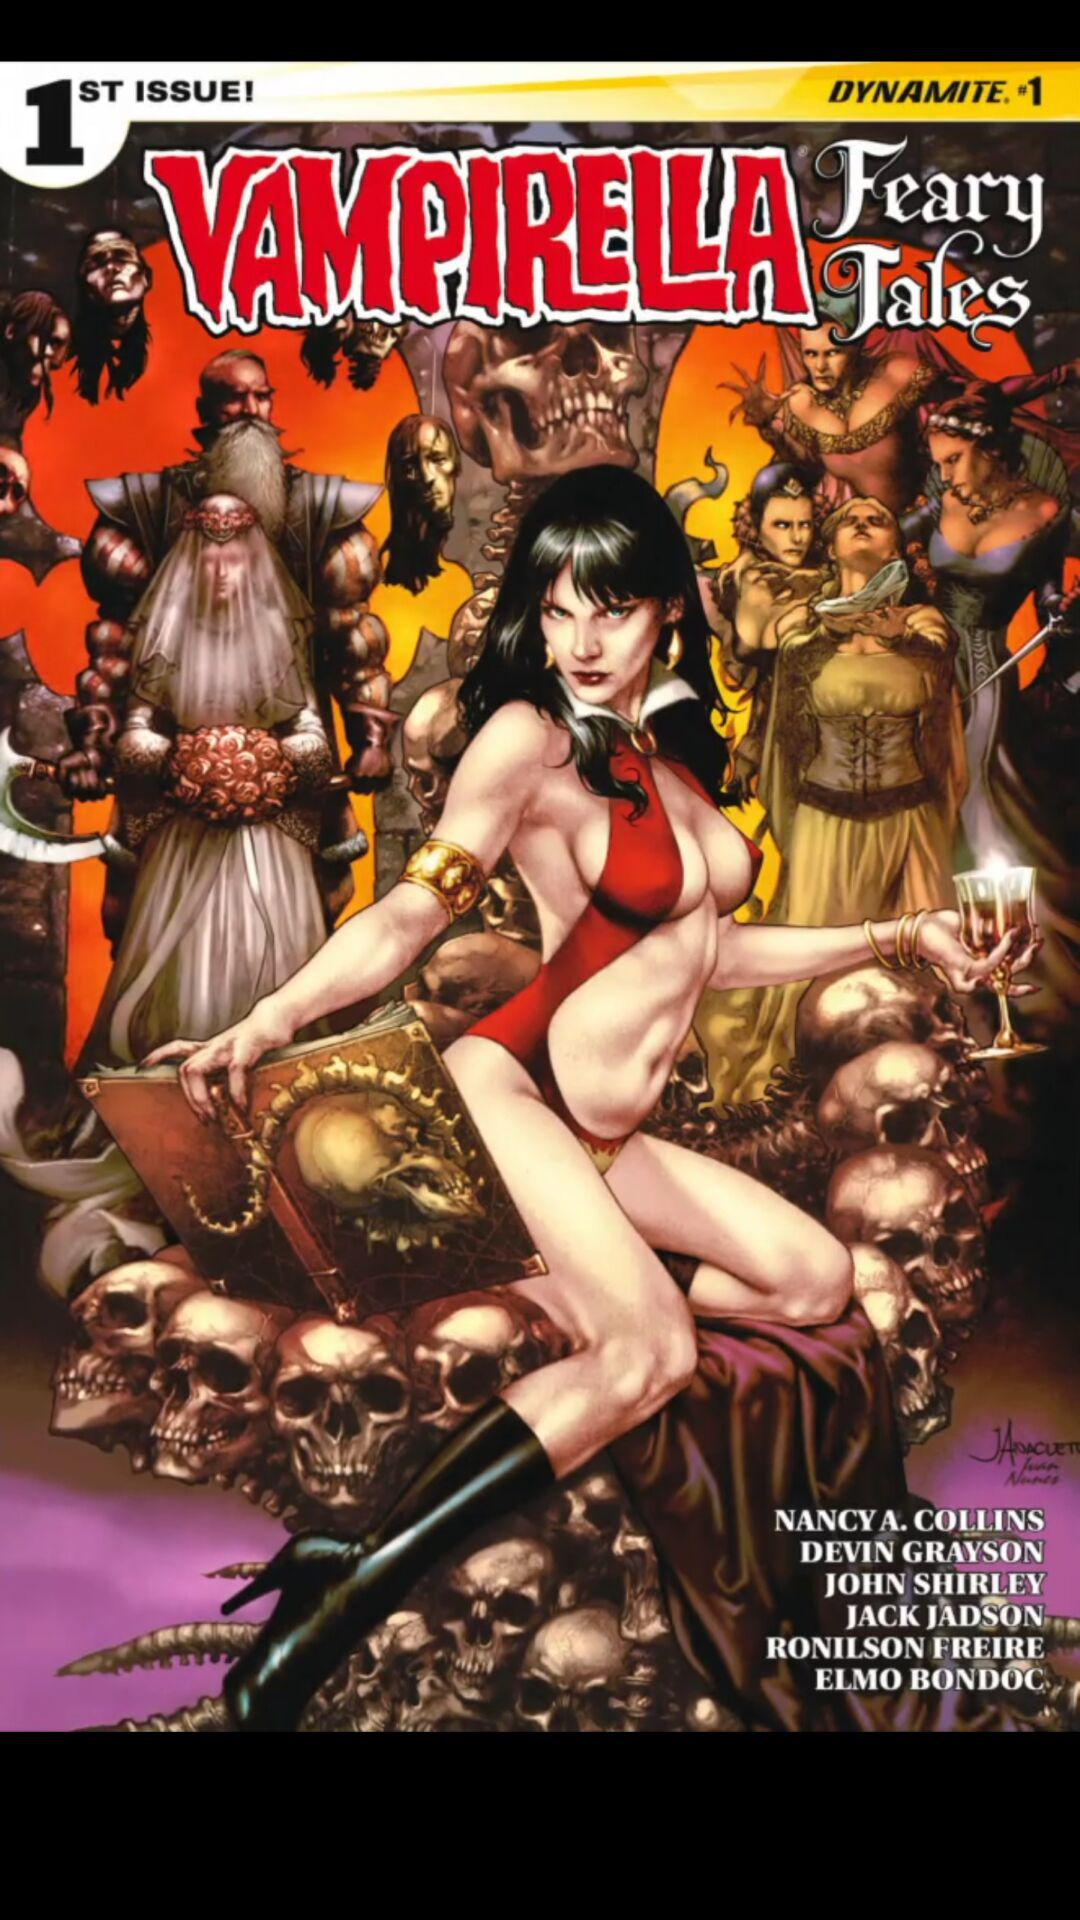Who is the author of the book? The authors of the book are Nancy A. Collins, Devin Grayson and John Shirley. 